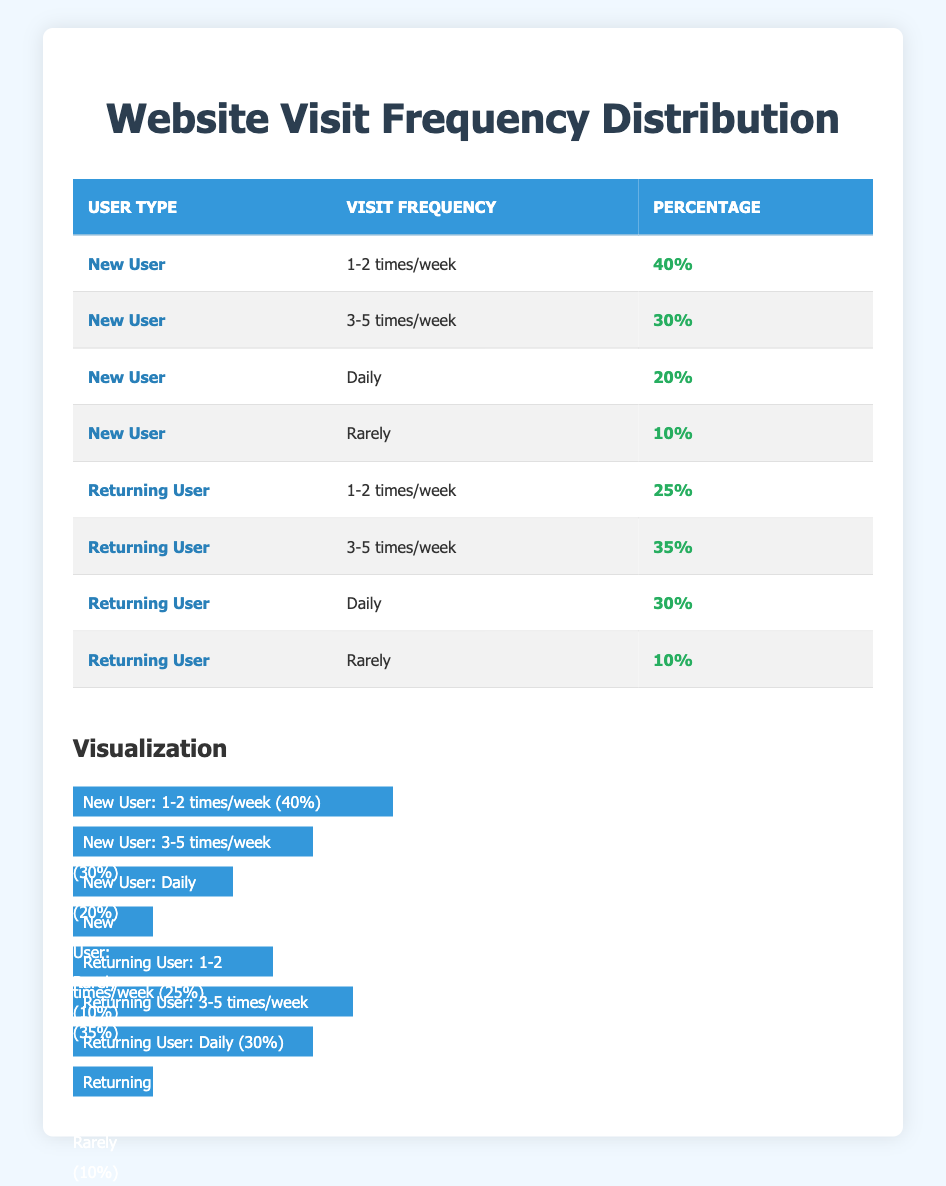What percentage of new users visit the website daily? According to the table, 20% of new users visit the website daily. This is clearly stated in the row corresponding to "New User" and "Daily".
Answer: 20% How many percentage points more do new users visit the website 1-2 times a week compared to returning users? From the table, new users visiting 1-2 times a week is 40%, while returning users is 25%. The difference is calculated as 40% - 25% = 15 percentage points.
Answer: 15 Is it true that returning users are more likely to visit the website 3-5 times a week than new users? Yes, the data shows that 35% of returning users visit 3-5 times a week, while only 30% of new users do. Comparing these percentages confirms this fact.
Answer: Yes What is the total percentage of new users who visit the website either daily or 3-5 times a week? The percentages of new users who visit daily (20%) and 3-5 times a week (30%) need to be added together. Therefore, 20% + 30% = 50%.
Answer: 50% Which user type has the lowest percentage of visits marked as "Rarely," and what is that percentage? The lowest percentage for "Rarely" is 10%, which applies to both new users and returning users as per the table. This is the same value for both categories.
Answer: 10% 